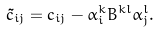Convert formula to latex. <formula><loc_0><loc_0><loc_500><loc_500>\tilde { c } _ { i j } = c _ { i j } - \alpha ^ { k } _ { i } B ^ { k l } \alpha ^ { l } _ { j } .</formula> 